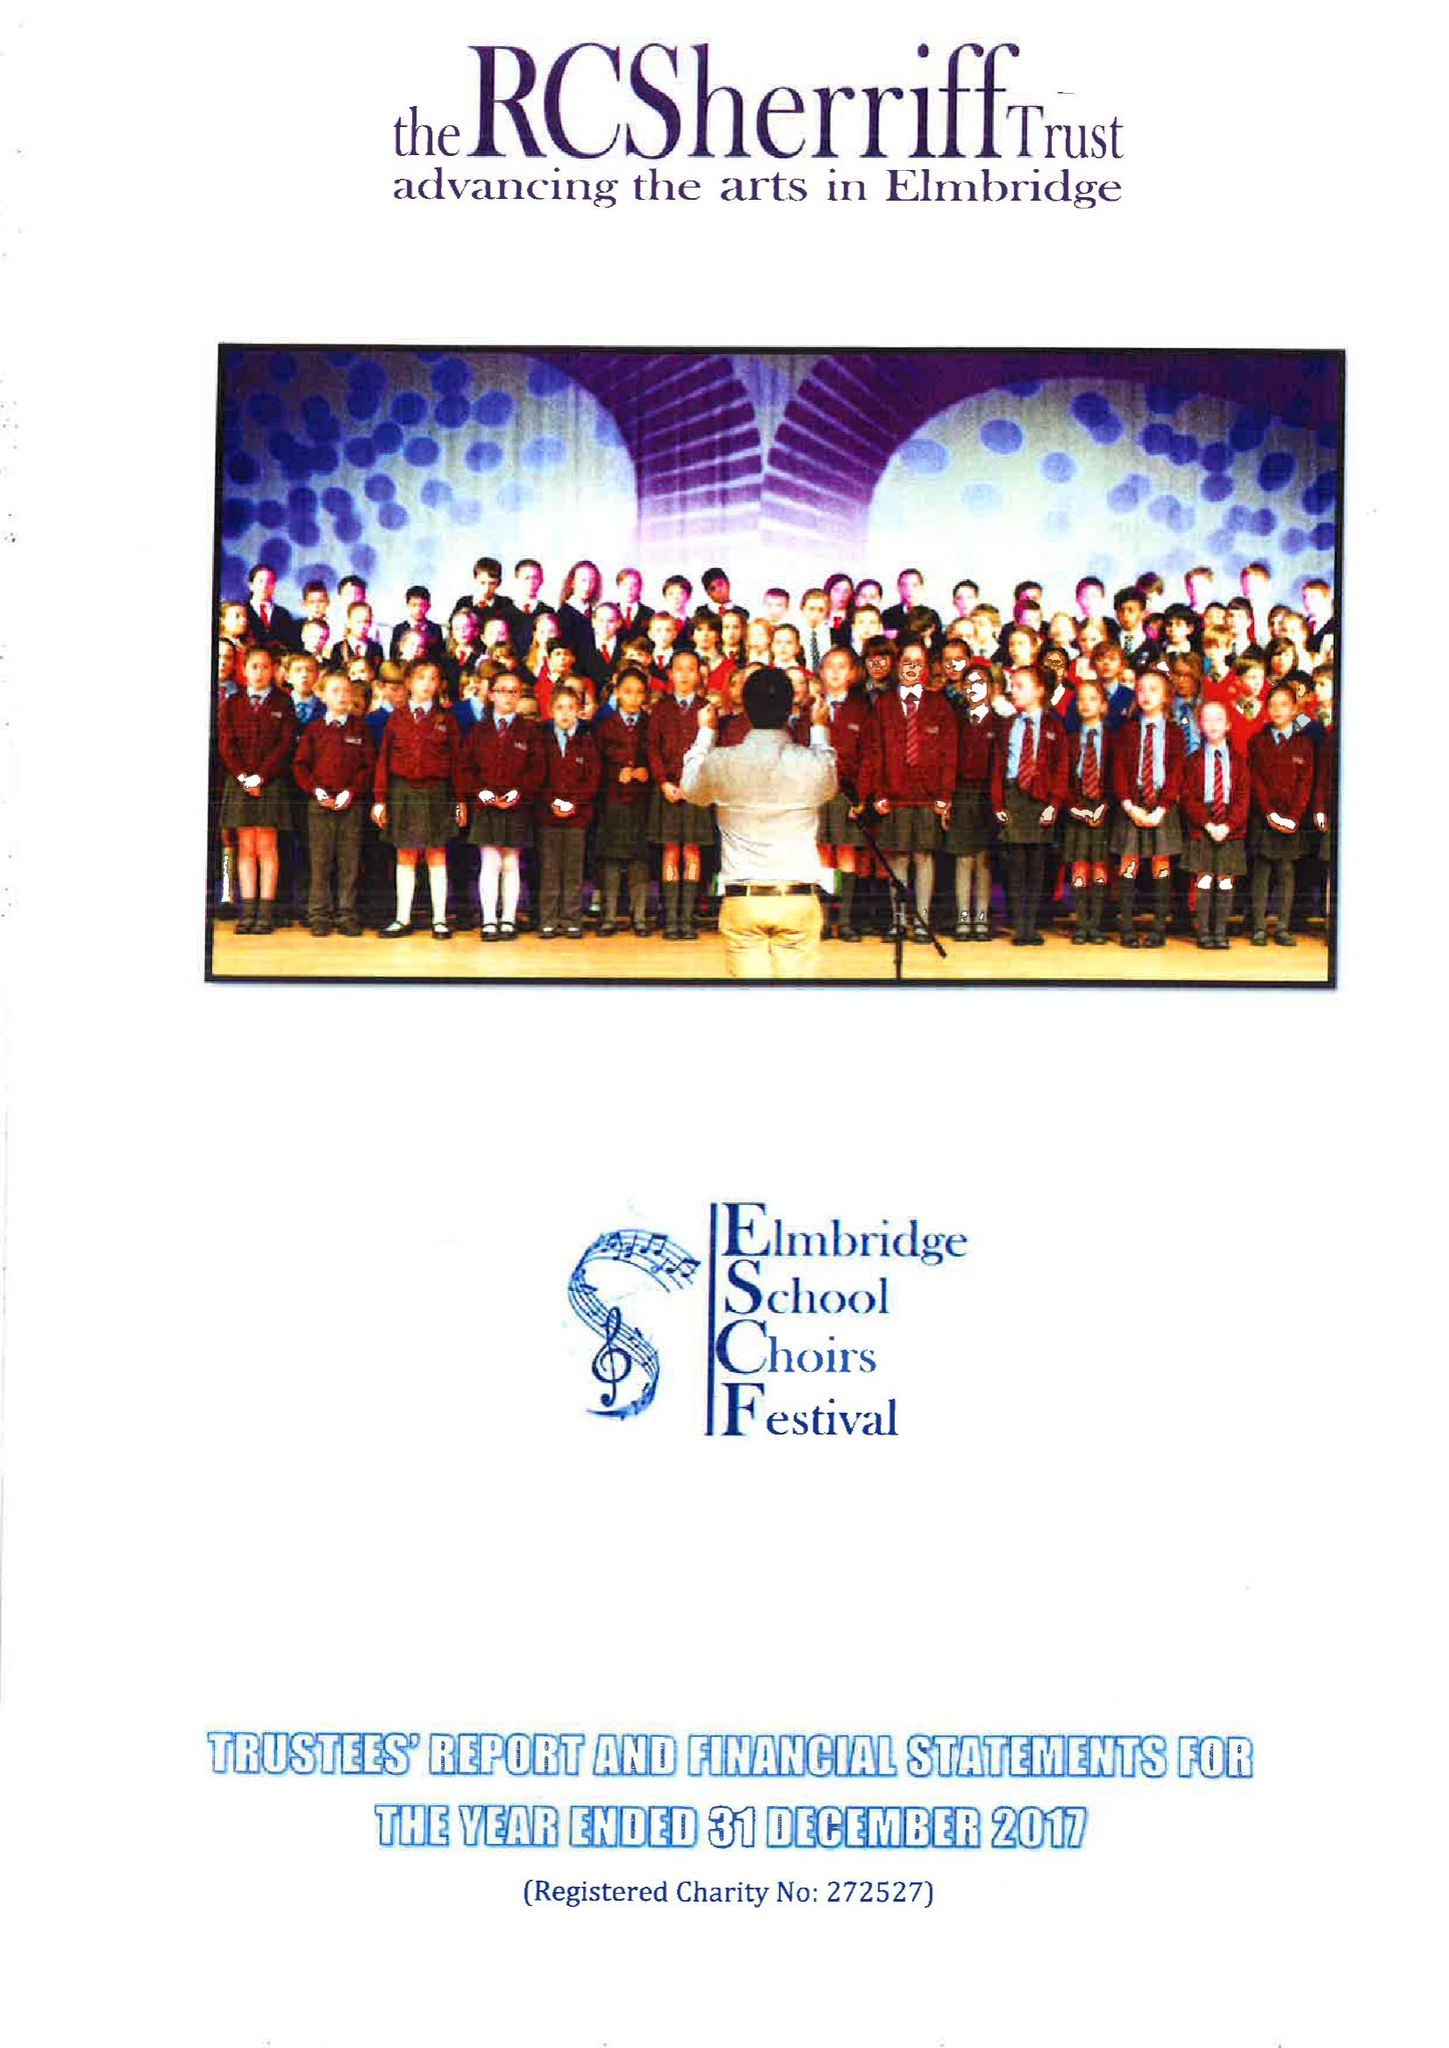What is the value for the address__postcode?
Answer the question using a single word or phrase. KT10 9SD 